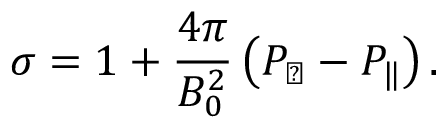Convert formula to latex. <formula><loc_0><loc_0><loc_500><loc_500>\sigma = 1 + \frac { 4 \pi } { B _ { 0 } ^ { 2 } } \left ( P _ { \perp } - P _ { \| } \right ) .</formula> 